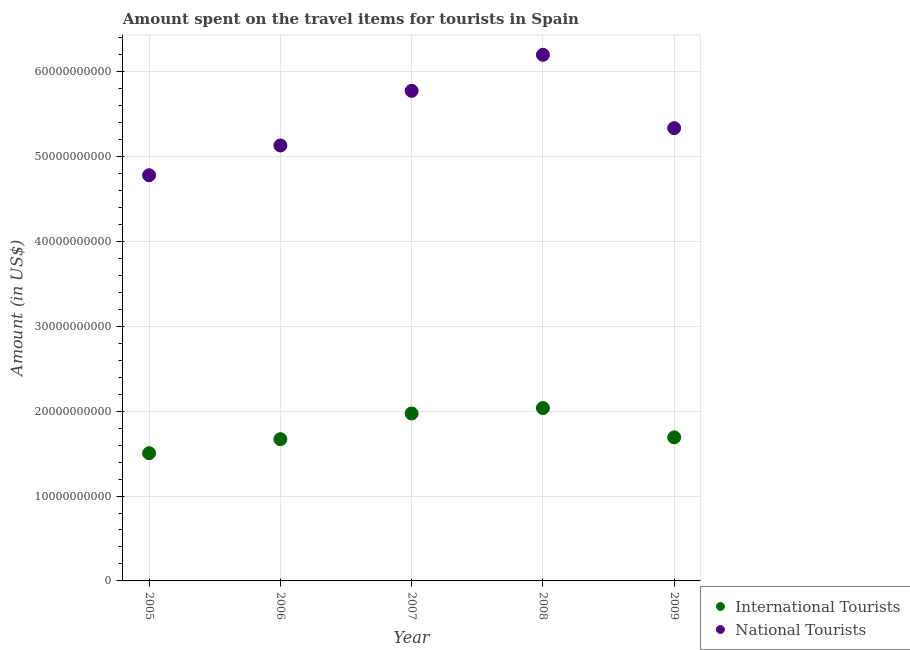Is the number of dotlines equal to the number of legend labels?
Offer a terse response. Yes. What is the amount spent on travel items of national tourists in 2005?
Keep it short and to the point. 4.78e+1. Across all years, what is the maximum amount spent on travel items of international tourists?
Your answer should be compact. 2.04e+1. Across all years, what is the minimum amount spent on travel items of international tourists?
Your answer should be very brief. 1.50e+1. In which year was the amount spent on travel items of national tourists minimum?
Offer a terse response. 2005. What is the total amount spent on travel items of international tourists in the graph?
Provide a short and direct response. 8.87e+1. What is the difference between the amount spent on travel items of international tourists in 2005 and that in 2009?
Offer a terse response. -1.86e+09. What is the difference between the amount spent on travel items of international tourists in 2006 and the amount spent on travel items of national tourists in 2008?
Your answer should be compact. -4.53e+1. What is the average amount spent on travel items of international tourists per year?
Offer a very short reply. 1.77e+1. In the year 2008, what is the difference between the amount spent on travel items of national tourists and amount spent on travel items of international tourists?
Give a very brief answer. 4.16e+1. In how many years, is the amount spent on travel items of national tourists greater than 60000000000 US$?
Your response must be concise. 1. What is the ratio of the amount spent on travel items of international tourists in 2008 to that in 2009?
Give a very brief answer. 1.2. What is the difference between the highest and the second highest amount spent on travel items of national tourists?
Offer a terse response. 4.24e+09. What is the difference between the highest and the lowest amount spent on travel items of international tourists?
Offer a terse response. 5.32e+09. Is the sum of the amount spent on travel items of national tourists in 2006 and 2009 greater than the maximum amount spent on travel items of international tourists across all years?
Keep it short and to the point. Yes. Is the amount spent on travel items of international tourists strictly less than the amount spent on travel items of national tourists over the years?
Ensure brevity in your answer.  Yes. How many dotlines are there?
Your answer should be compact. 2. How many years are there in the graph?
Your answer should be very brief. 5. What is the difference between two consecutive major ticks on the Y-axis?
Give a very brief answer. 1.00e+1. Does the graph contain any zero values?
Give a very brief answer. No. Does the graph contain grids?
Keep it short and to the point. Yes. Where does the legend appear in the graph?
Your response must be concise. Bottom right. What is the title of the graph?
Ensure brevity in your answer.  Amount spent on the travel items for tourists in Spain. What is the label or title of the Y-axis?
Offer a very short reply. Amount (in US$). What is the Amount (in US$) in International Tourists in 2005?
Offer a terse response. 1.50e+1. What is the Amount (in US$) of National Tourists in 2005?
Provide a short and direct response. 4.78e+1. What is the Amount (in US$) of International Tourists in 2006?
Make the answer very short. 1.67e+1. What is the Amount (in US$) in National Tourists in 2006?
Give a very brief answer. 5.13e+1. What is the Amount (in US$) in International Tourists in 2007?
Provide a short and direct response. 1.97e+1. What is the Amount (in US$) in National Tourists in 2007?
Provide a short and direct response. 5.77e+1. What is the Amount (in US$) of International Tourists in 2008?
Give a very brief answer. 2.04e+1. What is the Amount (in US$) in National Tourists in 2008?
Your response must be concise. 6.20e+1. What is the Amount (in US$) of International Tourists in 2009?
Provide a short and direct response. 1.69e+1. What is the Amount (in US$) of National Tourists in 2009?
Your answer should be compact. 5.33e+1. Across all years, what is the maximum Amount (in US$) of International Tourists?
Provide a succinct answer. 2.04e+1. Across all years, what is the maximum Amount (in US$) of National Tourists?
Make the answer very short. 6.20e+1. Across all years, what is the minimum Amount (in US$) of International Tourists?
Keep it short and to the point. 1.50e+1. Across all years, what is the minimum Amount (in US$) in National Tourists?
Keep it short and to the point. 4.78e+1. What is the total Amount (in US$) in International Tourists in the graph?
Provide a short and direct response. 8.87e+1. What is the total Amount (in US$) in National Tourists in the graph?
Your answer should be very brief. 2.72e+11. What is the difference between the Amount (in US$) of International Tourists in 2005 and that in 2006?
Offer a very short reply. -1.65e+09. What is the difference between the Amount (in US$) of National Tourists in 2005 and that in 2006?
Your response must be concise. -3.51e+09. What is the difference between the Amount (in US$) of International Tourists in 2005 and that in 2007?
Your response must be concise. -4.68e+09. What is the difference between the Amount (in US$) in National Tourists in 2005 and that in 2007?
Your response must be concise. -9.94e+09. What is the difference between the Amount (in US$) in International Tourists in 2005 and that in 2008?
Offer a terse response. -5.32e+09. What is the difference between the Amount (in US$) of National Tourists in 2005 and that in 2008?
Keep it short and to the point. -1.42e+1. What is the difference between the Amount (in US$) of International Tourists in 2005 and that in 2009?
Your response must be concise. -1.86e+09. What is the difference between the Amount (in US$) in National Tourists in 2005 and that in 2009?
Keep it short and to the point. -5.55e+09. What is the difference between the Amount (in US$) of International Tourists in 2006 and that in 2007?
Ensure brevity in your answer.  -3.03e+09. What is the difference between the Amount (in US$) in National Tourists in 2006 and that in 2007?
Give a very brief answer. -6.44e+09. What is the difference between the Amount (in US$) of International Tourists in 2006 and that in 2008?
Make the answer very short. -3.67e+09. What is the difference between the Amount (in US$) of National Tourists in 2006 and that in 2008?
Make the answer very short. -1.07e+1. What is the difference between the Amount (in US$) in International Tourists in 2006 and that in 2009?
Make the answer very short. -2.14e+08. What is the difference between the Amount (in US$) of National Tourists in 2006 and that in 2009?
Provide a short and direct response. -2.04e+09. What is the difference between the Amount (in US$) in International Tourists in 2007 and that in 2008?
Your answer should be compact. -6.39e+08. What is the difference between the Amount (in US$) of National Tourists in 2007 and that in 2008?
Offer a very short reply. -4.24e+09. What is the difference between the Amount (in US$) in International Tourists in 2007 and that in 2009?
Keep it short and to the point. 2.81e+09. What is the difference between the Amount (in US$) in National Tourists in 2007 and that in 2009?
Make the answer very short. 4.40e+09. What is the difference between the Amount (in US$) of International Tourists in 2008 and that in 2009?
Provide a short and direct response. 3.45e+09. What is the difference between the Amount (in US$) of National Tourists in 2008 and that in 2009?
Your answer should be very brief. 8.64e+09. What is the difference between the Amount (in US$) of International Tourists in 2005 and the Amount (in US$) of National Tourists in 2006?
Ensure brevity in your answer.  -3.63e+1. What is the difference between the Amount (in US$) in International Tourists in 2005 and the Amount (in US$) in National Tourists in 2007?
Your response must be concise. -4.27e+1. What is the difference between the Amount (in US$) in International Tourists in 2005 and the Amount (in US$) in National Tourists in 2008?
Your response must be concise. -4.69e+1. What is the difference between the Amount (in US$) of International Tourists in 2005 and the Amount (in US$) of National Tourists in 2009?
Your answer should be compact. -3.83e+1. What is the difference between the Amount (in US$) in International Tourists in 2006 and the Amount (in US$) in National Tourists in 2007?
Your response must be concise. -4.10e+1. What is the difference between the Amount (in US$) of International Tourists in 2006 and the Amount (in US$) of National Tourists in 2008?
Give a very brief answer. -4.53e+1. What is the difference between the Amount (in US$) in International Tourists in 2006 and the Amount (in US$) in National Tourists in 2009?
Your response must be concise. -3.66e+1. What is the difference between the Amount (in US$) of International Tourists in 2007 and the Amount (in US$) of National Tourists in 2008?
Provide a succinct answer. -4.23e+1. What is the difference between the Amount (in US$) in International Tourists in 2007 and the Amount (in US$) in National Tourists in 2009?
Offer a very short reply. -3.36e+1. What is the difference between the Amount (in US$) in International Tourists in 2008 and the Amount (in US$) in National Tourists in 2009?
Provide a short and direct response. -3.30e+1. What is the average Amount (in US$) in International Tourists per year?
Your response must be concise. 1.77e+1. What is the average Amount (in US$) in National Tourists per year?
Offer a very short reply. 5.44e+1. In the year 2005, what is the difference between the Amount (in US$) in International Tourists and Amount (in US$) in National Tourists?
Keep it short and to the point. -3.27e+1. In the year 2006, what is the difference between the Amount (in US$) in International Tourists and Amount (in US$) in National Tourists?
Keep it short and to the point. -3.46e+1. In the year 2007, what is the difference between the Amount (in US$) of International Tourists and Amount (in US$) of National Tourists?
Your response must be concise. -3.80e+1. In the year 2008, what is the difference between the Amount (in US$) in International Tourists and Amount (in US$) in National Tourists?
Provide a short and direct response. -4.16e+1. In the year 2009, what is the difference between the Amount (in US$) in International Tourists and Amount (in US$) in National Tourists?
Make the answer very short. -3.64e+1. What is the ratio of the Amount (in US$) of International Tourists in 2005 to that in 2006?
Offer a terse response. 0.9. What is the ratio of the Amount (in US$) in National Tourists in 2005 to that in 2006?
Your response must be concise. 0.93. What is the ratio of the Amount (in US$) in International Tourists in 2005 to that in 2007?
Ensure brevity in your answer.  0.76. What is the ratio of the Amount (in US$) of National Tourists in 2005 to that in 2007?
Offer a very short reply. 0.83. What is the ratio of the Amount (in US$) of International Tourists in 2005 to that in 2008?
Offer a terse response. 0.74. What is the ratio of the Amount (in US$) in National Tourists in 2005 to that in 2008?
Give a very brief answer. 0.77. What is the ratio of the Amount (in US$) in International Tourists in 2005 to that in 2009?
Give a very brief answer. 0.89. What is the ratio of the Amount (in US$) of National Tourists in 2005 to that in 2009?
Provide a succinct answer. 0.9. What is the ratio of the Amount (in US$) in International Tourists in 2006 to that in 2007?
Ensure brevity in your answer.  0.85. What is the ratio of the Amount (in US$) in National Tourists in 2006 to that in 2007?
Give a very brief answer. 0.89. What is the ratio of the Amount (in US$) in International Tourists in 2006 to that in 2008?
Your answer should be very brief. 0.82. What is the ratio of the Amount (in US$) of National Tourists in 2006 to that in 2008?
Make the answer very short. 0.83. What is the ratio of the Amount (in US$) of International Tourists in 2006 to that in 2009?
Ensure brevity in your answer.  0.99. What is the ratio of the Amount (in US$) of National Tourists in 2006 to that in 2009?
Offer a terse response. 0.96. What is the ratio of the Amount (in US$) in International Tourists in 2007 to that in 2008?
Make the answer very short. 0.97. What is the ratio of the Amount (in US$) in National Tourists in 2007 to that in 2008?
Your response must be concise. 0.93. What is the ratio of the Amount (in US$) in International Tourists in 2007 to that in 2009?
Offer a very short reply. 1.17. What is the ratio of the Amount (in US$) of National Tourists in 2007 to that in 2009?
Offer a terse response. 1.08. What is the ratio of the Amount (in US$) of International Tourists in 2008 to that in 2009?
Provide a short and direct response. 1.2. What is the ratio of the Amount (in US$) of National Tourists in 2008 to that in 2009?
Your answer should be compact. 1.16. What is the difference between the highest and the second highest Amount (in US$) of International Tourists?
Your response must be concise. 6.39e+08. What is the difference between the highest and the second highest Amount (in US$) of National Tourists?
Provide a short and direct response. 4.24e+09. What is the difference between the highest and the lowest Amount (in US$) of International Tourists?
Keep it short and to the point. 5.32e+09. What is the difference between the highest and the lowest Amount (in US$) in National Tourists?
Offer a terse response. 1.42e+1. 